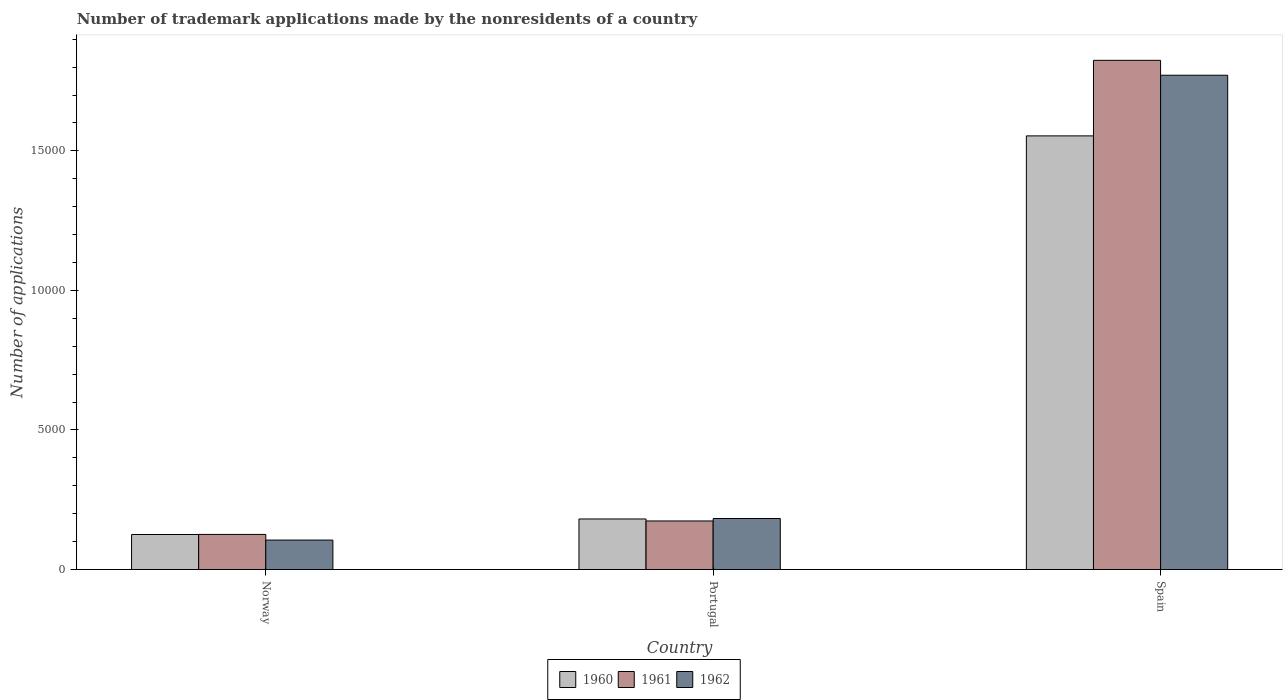How many different coloured bars are there?
Give a very brief answer. 3. How many groups of bars are there?
Offer a terse response. 3. Are the number of bars per tick equal to the number of legend labels?
Your response must be concise. Yes. Are the number of bars on each tick of the X-axis equal?
Provide a succinct answer. Yes. How many bars are there on the 1st tick from the left?
Ensure brevity in your answer.  3. In how many cases, is the number of bars for a given country not equal to the number of legend labels?
Provide a short and direct response. 0. What is the number of trademark applications made by the nonresidents in 1961 in Portugal?
Your answer should be very brief. 1740. Across all countries, what is the maximum number of trademark applications made by the nonresidents in 1960?
Offer a very short reply. 1.55e+04. Across all countries, what is the minimum number of trademark applications made by the nonresidents in 1960?
Your answer should be compact. 1255. In which country was the number of trademark applications made by the nonresidents in 1961 minimum?
Make the answer very short. Norway. What is the total number of trademark applications made by the nonresidents in 1962 in the graph?
Make the answer very short. 2.06e+04. What is the difference between the number of trademark applications made by the nonresidents in 1960 in Norway and that in Spain?
Your answer should be very brief. -1.43e+04. What is the difference between the number of trademark applications made by the nonresidents in 1961 in Spain and the number of trademark applications made by the nonresidents in 1962 in Norway?
Keep it short and to the point. 1.72e+04. What is the average number of trademark applications made by the nonresidents in 1962 per country?
Your response must be concise. 6864.33. What is the difference between the number of trademark applications made by the nonresidents of/in 1962 and number of trademark applications made by the nonresidents of/in 1961 in Portugal?
Keep it short and to the point. 88. What is the ratio of the number of trademark applications made by the nonresidents in 1960 in Norway to that in Portugal?
Provide a short and direct response. 0.69. Is the number of trademark applications made by the nonresidents in 1960 in Portugal less than that in Spain?
Offer a terse response. Yes. What is the difference between the highest and the second highest number of trademark applications made by the nonresidents in 1960?
Keep it short and to the point. 1.37e+04. What is the difference between the highest and the lowest number of trademark applications made by the nonresidents in 1960?
Your answer should be very brief. 1.43e+04. Is the sum of the number of trademark applications made by the nonresidents in 1961 in Norway and Spain greater than the maximum number of trademark applications made by the nonresidents in 1960 across all countries?
Give a very brief answer. Yes. Is it the case that in every country, the sum of the number of trademark applications made by the nonresidents in 1961 and number of trademark applications made by the nonresidents in 1962 is greater than the number of trademark applications made by the nonresidents in 1960?
Your response must be concise. Yes. How many bars are there?
Keep it short and to the point. 9. Are all the bars in the graph horizontal?
Give a very brief answer. No. What is the difference between two consecutive major ticks on the Y-axis?
Offer a terse response. 5000. Does the graph contain grids?
Your answer should be very brief. No. Where does the legend appear in the graph?
Make the answer very short. Bottom center. How many legend labels are there?
Make the answer very short. 3. What is the title of the graph?
Offer a very short reply. Number of trademark applications made by the nonresidents of a country. Does "1981" appear as one of the legend labels in the graph?
Provide a succinct answer. No. What is the label or title of the Y-axis?
Offer a terse response. Number of applications. What is the Number of applications of 1960 in Norway?
Offer a very short reply. 1255. What is the Number of applications of 1961 in Norway?
Your answer should be compact. 1258. What is the Number of applications in 1962 in Norway?
Offer a very short reply. 1055. What is the Number of applications of 1960 in Portugal?
Provide a short and direct response. 1811. What is the Number of applications of 1961 in Portugal?
Your answer should be compact. 1740. What is the Number of applications of 1962 in Portugal?
Make the answer very short. 1828. What is the Number of applications of 1960 in Spain?
Keep it short and to the point. 1.55e+04. What is the Number of applications in 1961 in Spain?
Provide a short and direct response. 1.82e+04. What is the Number of applications of 1962 in Spain?
Offer a terse response. 1.77e+04. Across all countries, what is the maximum Number of applications of 1960?
Provide a succinct answer. 1.55e+04. Across all countries, what is the maximum Number of applications of 1961?
Your response must be concise. 1.82e+04. Across all countries, what is the maximum Number of applications in 1962?
Offer a very short reply. 1.77e+04. Across all countries, what is the minimum Number of applications of 1960?
Make the answer very short. 1255. Across all countries, what is the minimum Number of applications of 1961?
Make the answer very short. 1258. Across all countries, what is the minimum Number of applications in 1962?
Provide a short and direct response. 1055. What is the total Number of applications of 1960 in the graph?
Provide a short and direct response. 1.86e+04. What is the total Number of applications in 1961 in the graph?
Provide a short and direct response. 2.12e+04. What is the total Number of applications in 1962 in the graph?
Keep it short and to the point. 2.06e+04. What is the difference between the Number of applications of 1960 in Norway and that in Portugal?
Provide a short and direct response. -556. What is the difference between the Number of applications in 1961 in Norway and that in Portugal?
Ensure brevity in your answer.  -482. What is the difference between the Number of applications in 1962 in Norway and that in Portugal?
Keep it short and to the point. -773. What is the difference between the Number of applications in 1960 in Norway and that in Spain?
Offer a terse response. -1.43e+04. What is the difference between the Number of applications of 1961 in Norway and that in Spain?
Keep it short and to the point. -1.70e+04. What is the difference between the Number of applications in 1962 in Norway and that in Spain?
Offer a very short reply. -1.67e+04. What is the difference between the Number of applications of 1960 in Portugal and that in Spain?
Provide a short and direct response. -1.37e+04. What is the difference between the Number of applications of 1961 in Portugal and that in Spain?
Offer a very short reply. -1.65e+04. What is the difference between the Number of applications of 1962 in Portugal and that in Spain?
Keep it short and to the point. -1.59e+04. What is the difference between the Number of applications in 1960 in Norway and the Number of applications in 1961 in Portugal?
Keep it short and to the point. -485. What is the difference between the Number of applications of 1960 in Norway and the Number of applications of 1962 in Portugal?
Keep it short and to the point. -573. What is the difference between the Number of applications of 1961 in Norway and the Number of applications of 1962 in Portugal?
Make the answer very short. -570. What is the difference between the Number of applications in 1960 in Norway and the Number of applications in 1961 in Spain?
Provide a short and direct response. -1.70e+04. What is the difference between the Number of applications in 1960 in Norway and the Number of applications in 1962 in Spain?
Provide a succinct answer. -1.65e+04. What is the difference between the Number of applications of 1961 in Norway and the Number of applications of 1962 in Spain?
Ensure brevity in your answer.  -1.65e+04. What is the difference between the Number of applications of 1960 in Portugal and the Number of applications of 1961 in Spain?
Give a very brief answer. -1.64e+04. What is the difference between the Number of applications of 1960 in Portugal and the Number of applications of 1962 in Spain?
Provide a succinct answer. -1.59e+04. What is the difference between the Number of applications of 1961 in Portugal and the Number of applications of 1962 in Spain?
Keep it short and to the point. -1.60e+04. What is the average Number of applications of 1960 per country?
Provide a short and direct response. 6201. What is the average Number of applications of 1961 per country?
Your answer should be compact. 7080.67. What is the average Number of applications of 1962 per country?
Give a very brief answer. 6864.33. What is the difference between the Number of applications in 1960 and Number of applications in 1962 in Norway?
Your response must be concise. 200. What is the difference between the Number of applications of 1961 and Number of applications of 1962 in Norway?
Provide a short and direct response. 203. What is the difference between the Number of applications in 1961 and Number of applications in 1962 in Portugal?
Offer a very short reply. -88. What is the difference between the Number of applications in 1960 and Number of applications in 1961 in Spain?
Your answer should be compact. -2707. What is the difference between the Number of applications in 1960 and Number of applications in 1962 in Spain?
Your answer should be compact. -2173. What is the difference between the Number of applications in 1961 and Number of applications in 1962 in Spain?
Keep it short and to the point. 534. What is the ratio of the Number of applications of 1960 in Norway to that in Portugal?
Your response must be concise. 0.69. What is the ratio of the Number of applications of 1961 in Norway to that in Portugal?
Give a very brief answer. 0.72. What is the ratio of the Number of applications of 1962 in Norway to that in Portugal?
Provide a short and direct response. 0.58. What is the ratio of the Number of applications of 1960 in Norway to that in Spain?
Provide a short and direct response. 0.08. What is the ratio of the Number of applications in 1961 in Norway to that in Spain?
Provide a short and direct response. 0.07. What is the ratio of the Number of applications in 1962 in Norway to that in Spain?
Your response must be concise. 0.06. What is the ratio of the Number of applications in 1960 in Portugal to that in Spain?
Offer a terse response. 0.12. What is the ratio of the Number of applications of 1961 in Portugal to that in Spain?
Keep it short and to the point. 0.1. What is the ratio of the Number of applications of 1962 in Portugal to that in Spain?
Ensure brevity in your answer.  0.1. What is the difference between the highest and the second highest Number of applications in 1960?
Provide a short and direct response. 1.37e+04. What is the difference between the highest and the second highest Number of applications in 1961?
Ensure brevity in your answer.  1.65e+04. What is the difference between the highest and the second highest Number of applications in 1962?
Ensure brevity in your answer.  1.59e+04. What is the difference between the highest and the lowest Number of applications in 1960?
Your answer should be compact. 1.43e+04. What is the difference between the highest and the lowest Number of applications in 1961?
Give a very brief answer. 1.70e+04. What is the difference between the highest and the lowest Number of applications of 1962?
Offer a very short reply. 1.67e+04. 